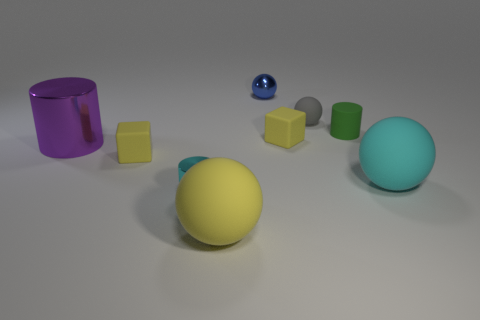Subtract all blocks. How many objects are left? 7 Add 2 metallic objects. How many metallic objects are left? 5 Add 7 gray spheres. How many gray spheres exist? 8 Subtract 0 cyan blocks. How many objects are left? 9 Subtract all green rubber cylinders. Subtract all tiny green cylinders. How many objects are left? 7 